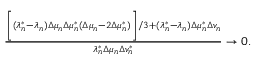<formula> <loc_0><loc_0><loc_500><loc_500>\begin{array} { r } { \frac { \left [ ( \lambda _ { n } ^ { * } - \lambda _ { n } ) \Delta \mu _ { n } \Delta \mu _ { n } ^ { * } ( \Delta \mu _ { n } - 2 \Delta \mu _ { n } ^ { * } ) \right ] / 3 + ( \lambda _ { n } ^ { * } - \lambda _ { n } ) \Delta \mu _ { n } ^ { * } \Delta v _ { n } } { \lambda _ { n } ^ { * } \Delta \mu _ { n } \Delta v _ { n } ^ { * } } \to 0 . } \end{array}</formula> 